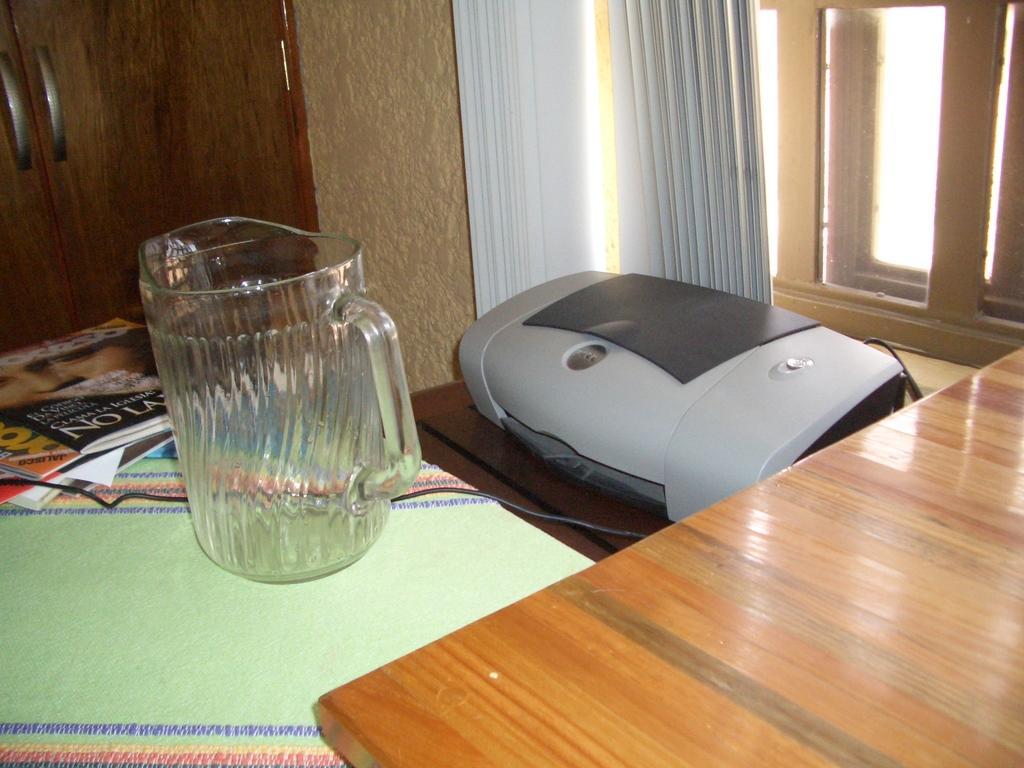Could you give a brief overview of what you see in this image? This is a table covered with green color cloth. These are the magazines,glass jar and machine placed on the table. This is a another wooden table. This looks like a window door. I think these are the curtains hanging. This is a door with a door handle. 